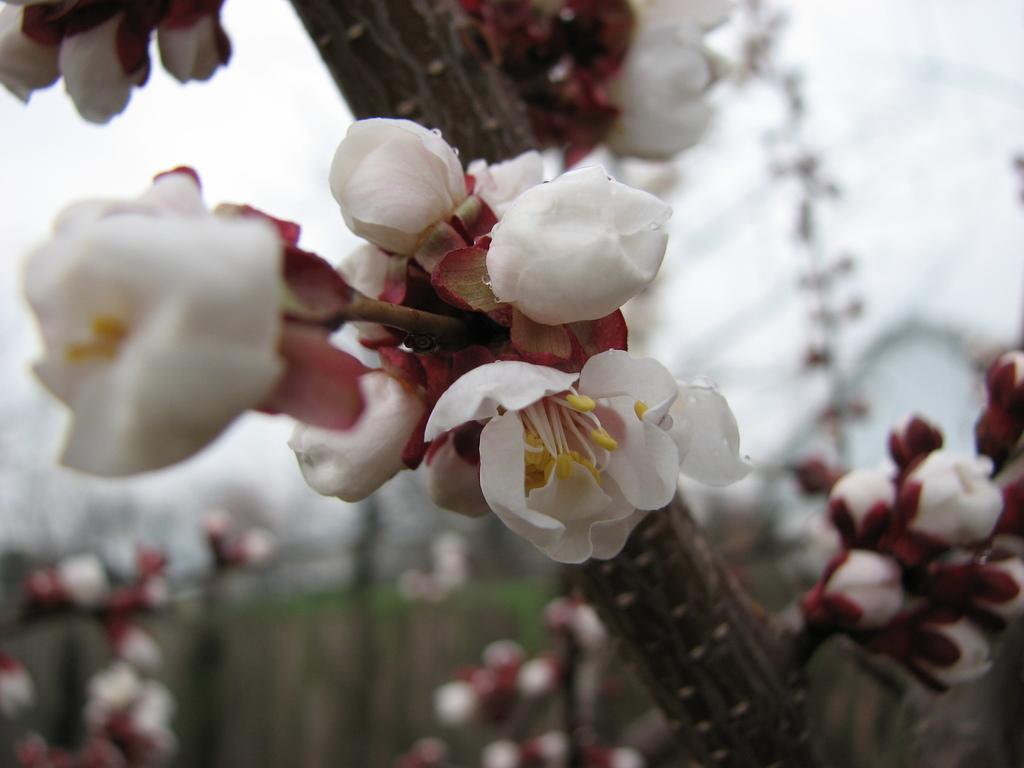Describe this image in one or two sentences. In this image there are flowers. 